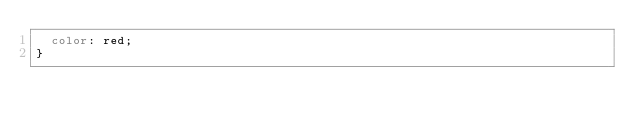<code> <loc_0><loc_0><loc_500><loc_500><_CSS_>  color: red;
}
</code> 